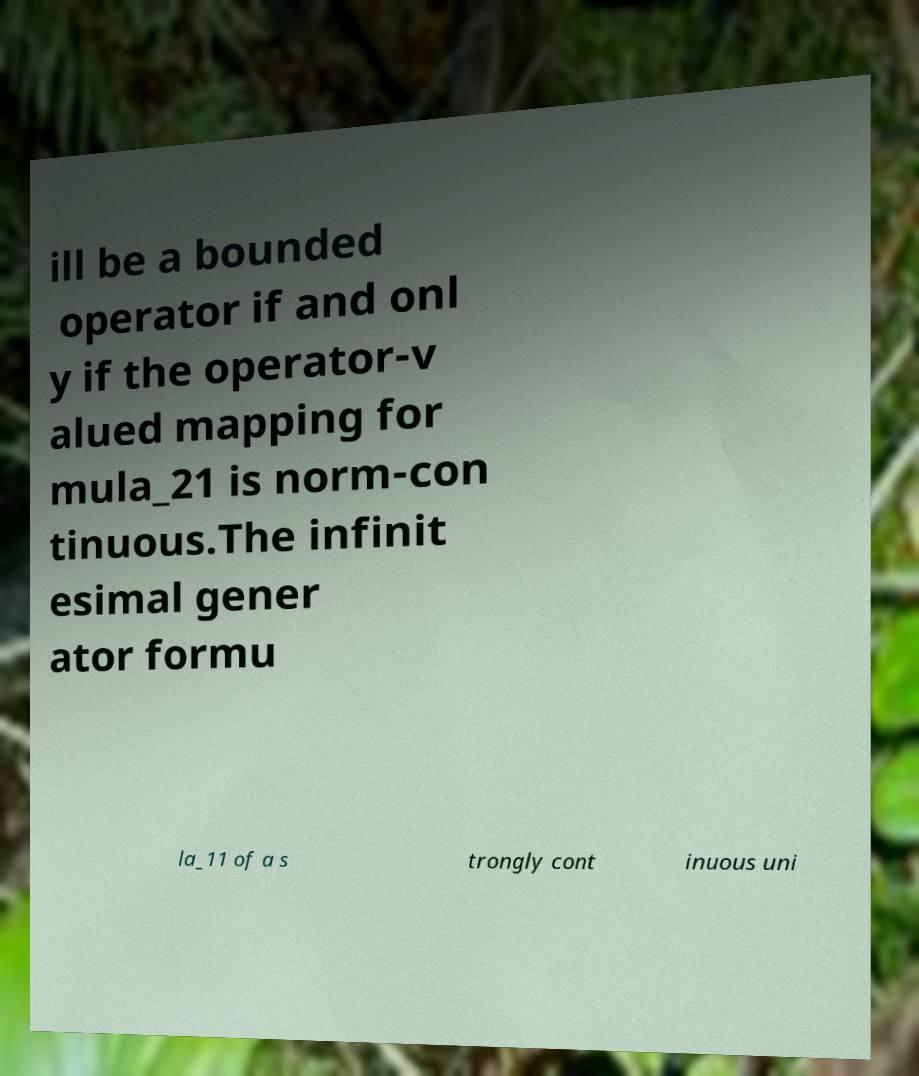Can you accurately transcribe the text from the provided image for me? ill be a bounded operator if and onl y if the operator-v alued mapping for mula_21 is norm-con tinuous.The infinit esimal gener ator formu la_11 of a s trongly cont inuous uni 